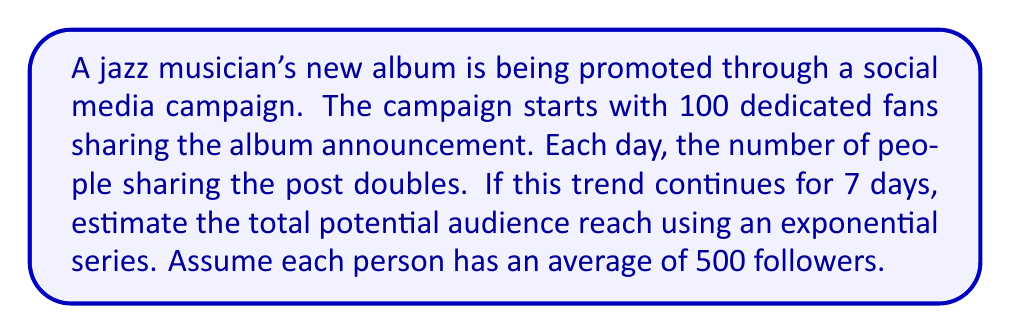Can you answer this question? Let's approach this step-by-step:

1) The number of people sharing each day forms a geometric sequence:
   Day 1: 100
   Day 2: 200
   Day 3: 400
   ...and so on

2) This can be represented by the exponential function:
   $a_n = 100 \cdot 2^{n-1}$, where $n$ is the day number

3) To find the total number of people sharing over 7 days, we need to sum this series:
   $S = 100 + 200 + 400 + 800 + 1600 + 3200 + 6400$

4) This is a geometric series with first term $a=100$ and common ratio $r=2$
   The sum of a geometric series is given by the formula:
   $S = \frac{a(1-r^n)}{1-r}$, where $n$ is the number of terms

5) Substituting our values:
   $S = \frac{100(1-2^7)}{1-2} = 100(2^7 - 1) = 100(128 - 1) = 12,700$

6) This is the number of people sharing. To get the potential audience reach, multiply by the average number of followers:
   $12,700 \cdot 500 = 6,350,000$

Therefore, the estimated potential audience reach is 6,350,000 people.
Answer: 6,350,000 